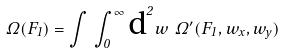Convert formula to latex. <formula><loc_0><loc_0><loc_500><loc_500>\Omega ( F _ { 1 } ) = \int \, \int _ { 0 } ^ { \infty } \text {d} ^ { 2 } w \ \Omega ^ { \prime } ( F _ { 1 } , w _ { x } , w _ { y } )</formula> 